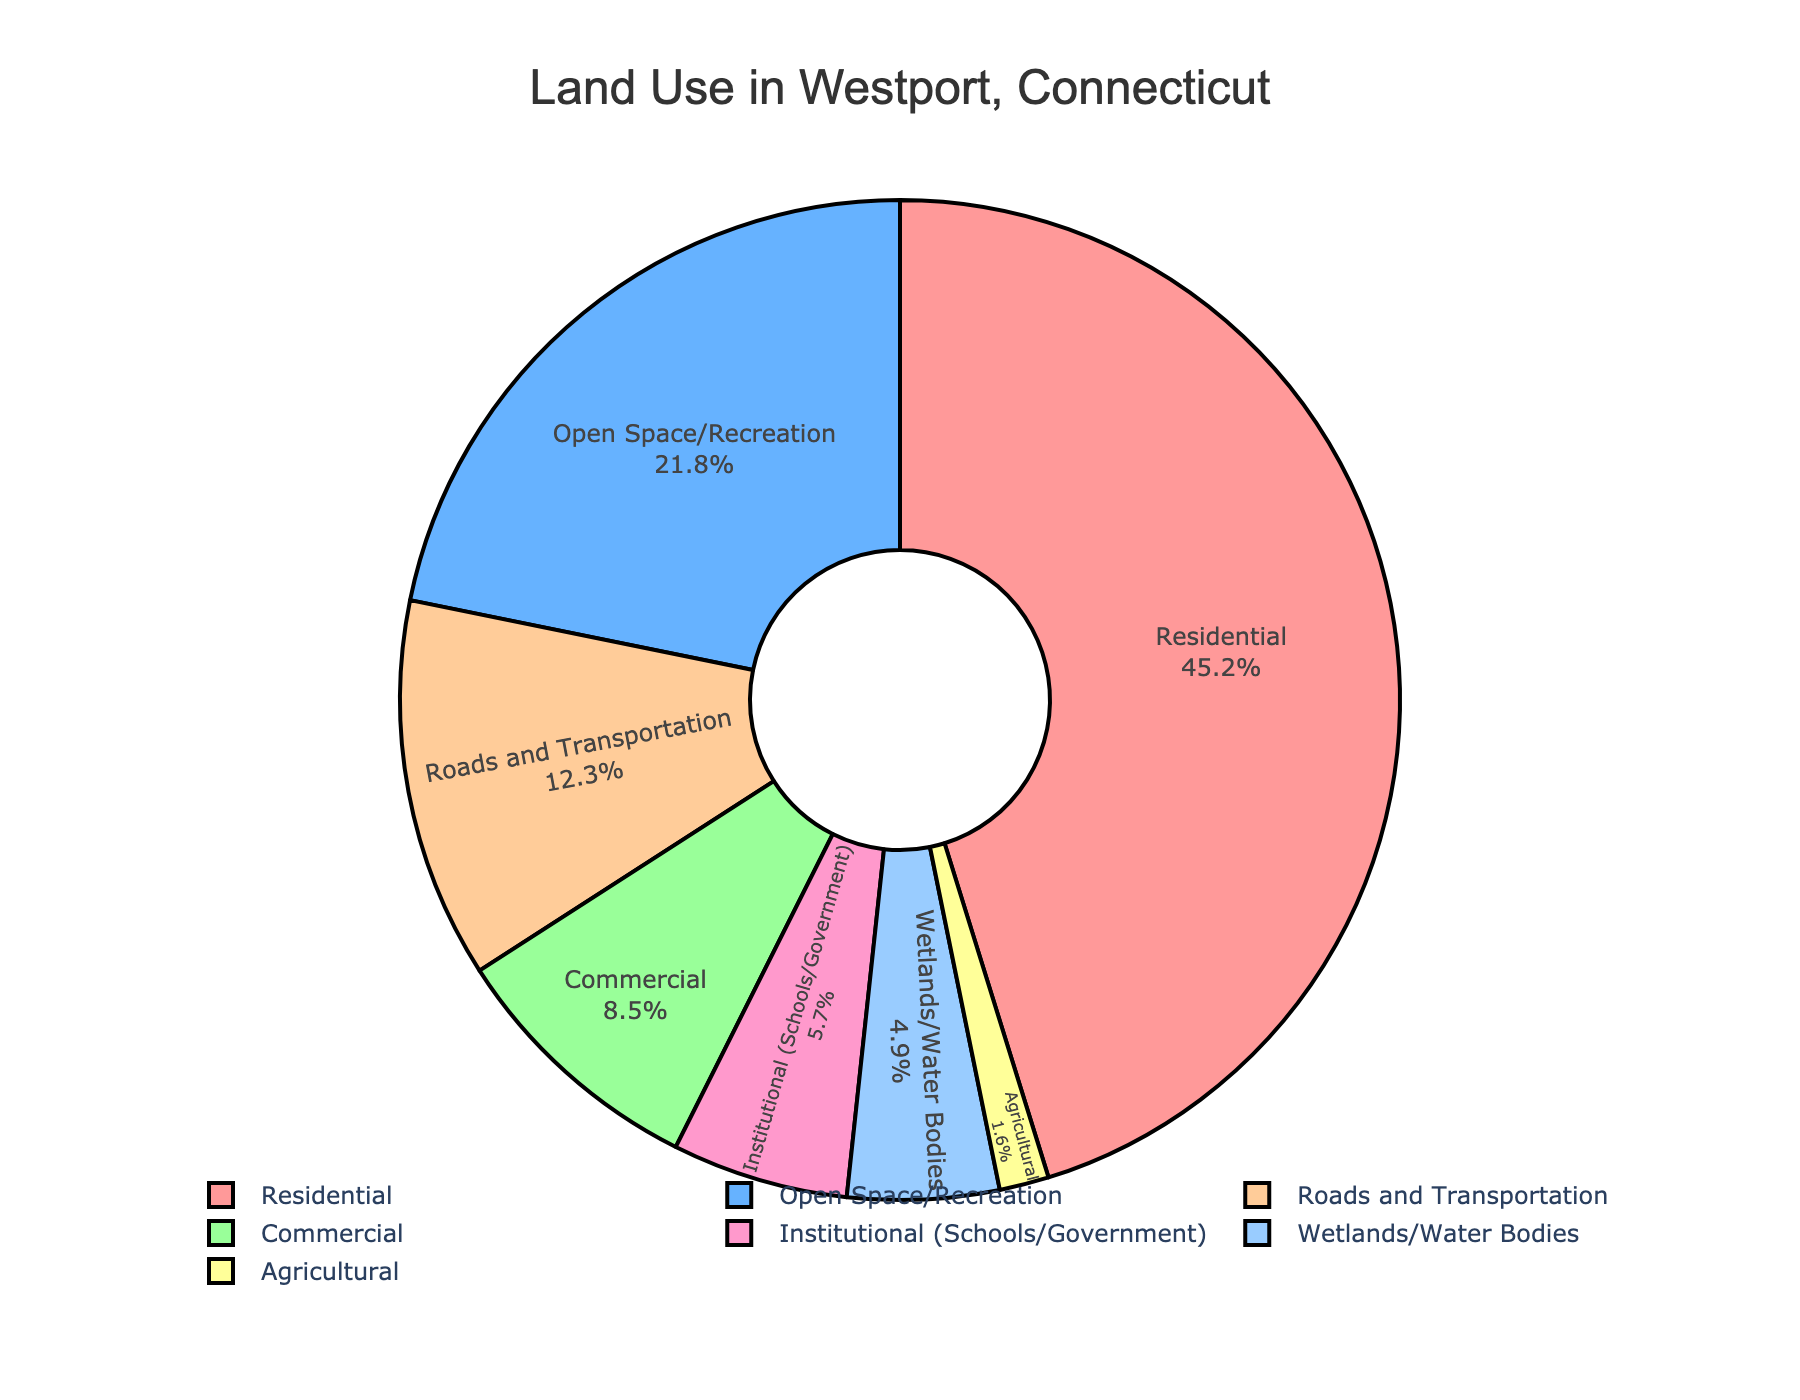Which category of land use covers the largest area? By visually inspecting the pie chart, the largest slice represents the "Residential" category.
Answer: Residential How much larger is the residential area compared to the commercial area? The residential area is 45.2%, and the commercial area is 8.5%. The difference is calculated as 45.2% - 8.5% = 36.7%.
Answer: 36.7% Which two categories have a combined percentage closest to half of the total land use? By adding different combinations, "Residential" (45.2%) and "Institutional (Schools/Government)" (5.7%) together make 45.2% + 5.7% = 50.9%, which is the closest to 50%.
Answer: Residential and Institutional (Schools/Government) Which category occupies the smallest land area in Westport? The smallest slice on the pie chart corresponds to "Agricultural" with a percentage of 1.6%.
Answer: Agricultural What is the total percentage of land used for roads and open spaces combined? The percentage for "Roads and Transportation" is 12.3%, and for "Open Space/Recreation" it's 21.8%. Combined, they make 12.3% + 21.8% = 34.1%.
Answer: 34.1% Is the percentage of land used for wetlands/water bodies greater than that used for institutional purposes? The percentage for "Wetlands/Water Bodies" is 4.9%, and for "Institutional (Schools/Government)" it is 5.7%. Therefore, 4.9% is less than 5.7%.
Answer: No If the total land area of Westport is 20 square miles, what is the approximate area used for open space/recreation? Given that open space/recreation takes up 21.8% of the total land, the area is 21.8% of 20 square miles. So, 0.218 * 20 = 4.36 square miles.
Answer: 4.36 square miles How does the percentage of land used for commercial purposes compare to that for roads and transportation? The commercial area is 8.5%, and the roads and transportation area is 12.3%. Since 8.5% < 12.3%, land used for commercial purposes is less than that for roads and transportation.
Answer: Less What is the sum of the land percentages used for residential and agricultural purposes? Percentage of residential land is 45.2%, and agricultural land is 1.6%. The sum is 45.2% + 1.6% = 46.8%.
Answer: 46.8% Does the sum of land used for residential, commercial, and agricultural purposes exceed 50% of the total land? Adding up the percentages: 45.2% (residential) + 8.5% (commercial) + 1.6% (agricultural) = 55.3%. This exceeds 50%.
Answer: Yes 